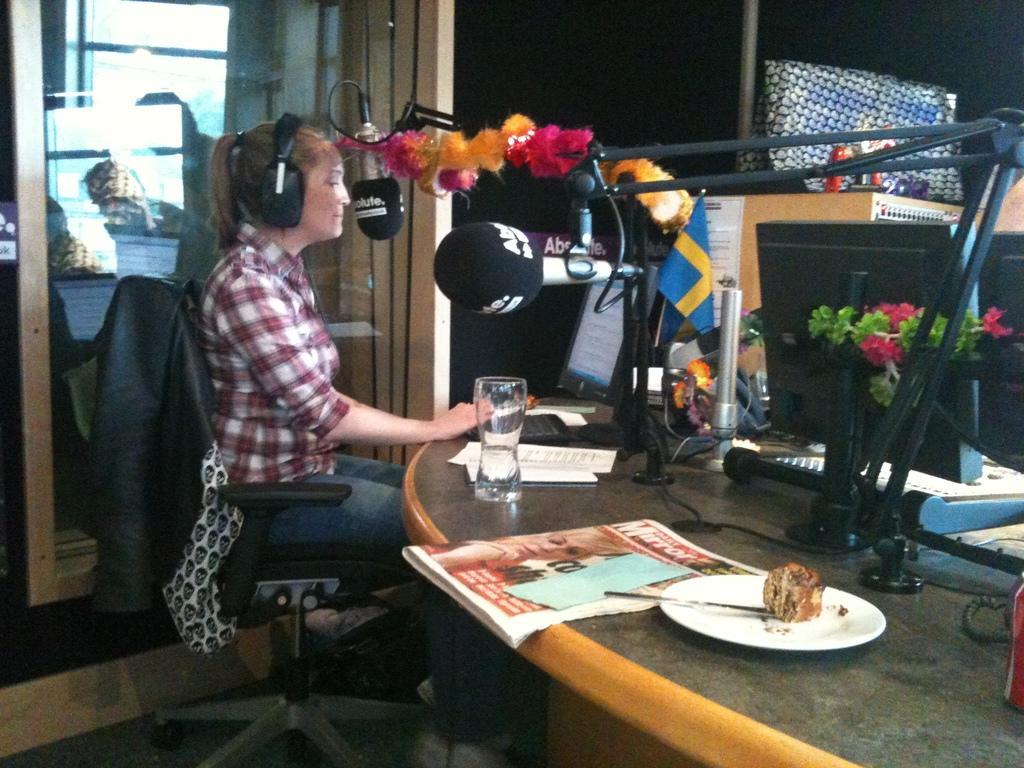Can you describe this image briefly? This picture shows a woman seated on the chair and she wore a headset and we see microphones and few papers and and a glass and some food in the plate and a knife on the table and we see a monitor and we see few artificial flowers.. 